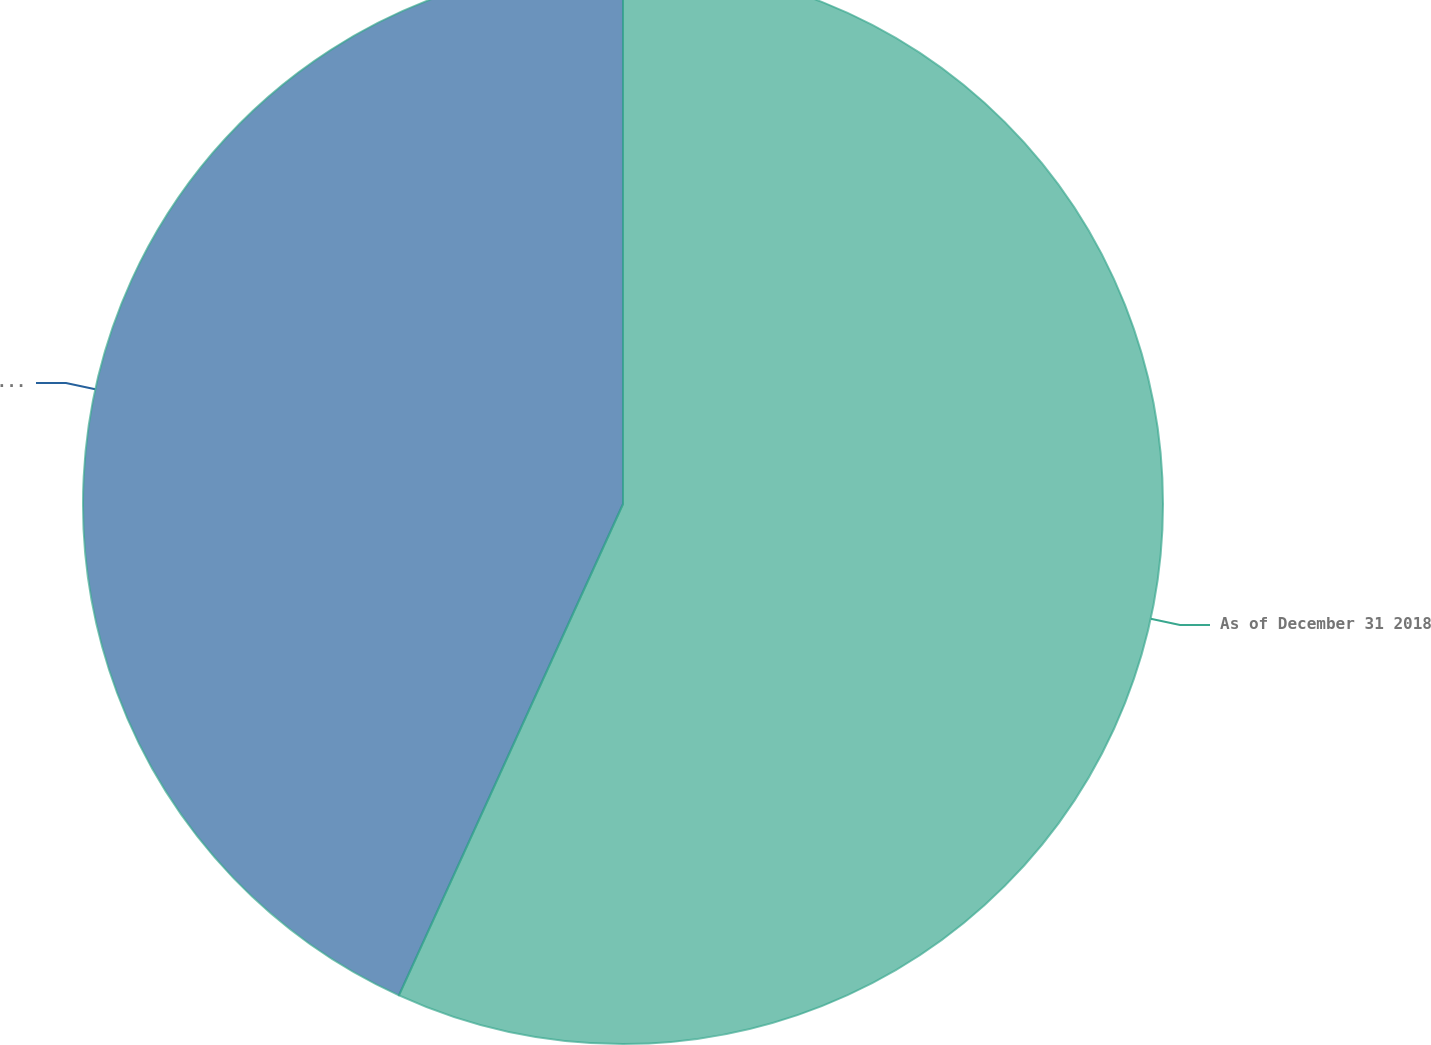Convert chart to OTSL. <chart><loc_0><loc_0><loc_500><loc_500><pie_chart><fcel>As of December 31 2018<fcel>Corporate debt<nl><fcel>56.81%<fcel>43.19%<nl></chart> 